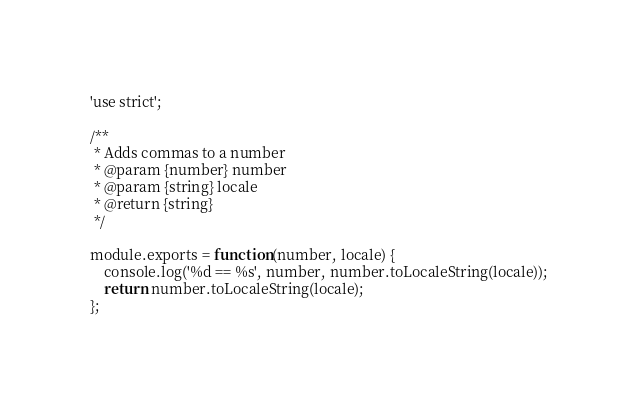<code> <loc_0><loc_0><loc_500><loc_500><_JavaScript_>'use strict';

/**
 * Adds commas to a number
 * @param {number} number
 * @param {string} locale
 * @return {string} 
 */

module.exports = function(number, locale) {
	console.log('%d == %s', number, number.toLocaleString(locale));
	return number.toLocaleString(locale);
};
</code> 